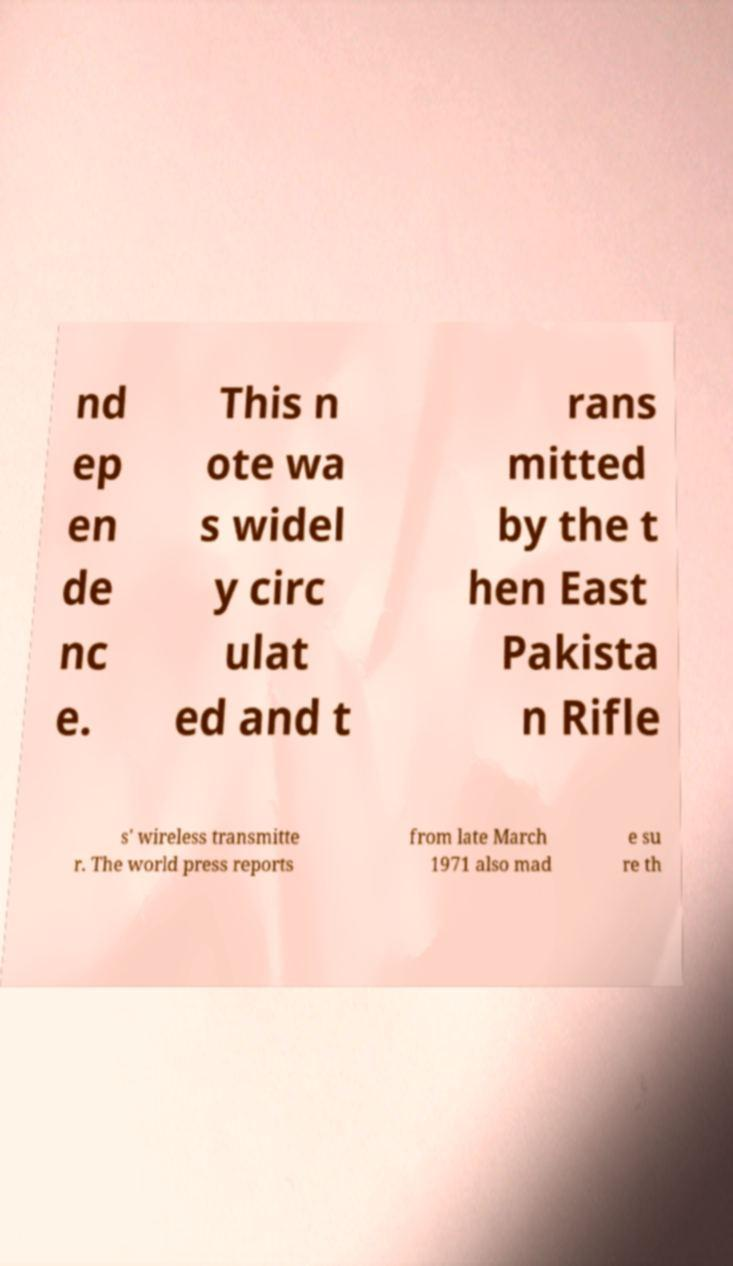Could you assist in decoding the text presented in this image and type it out clearly? nd ep en de nc e. This n ote wa s widel y circ ulat ed and t rans mitted by the t hen East Pakista n Rifle s' wireless transmitte r. The world press reports from late March 1971 also mad e su re th 